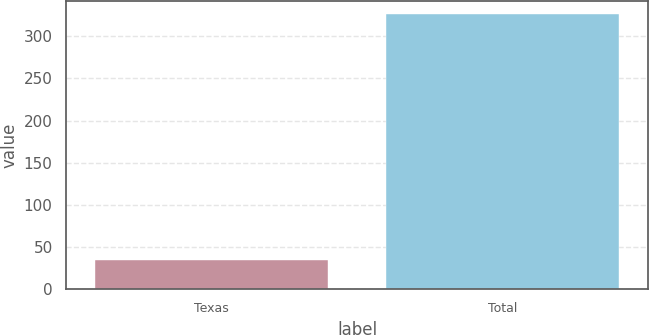Convert chart to OTSL. <chart><loc_0><loc_0><loc_500><loc_500><bar_chart><fcel>Texas<fcel>Total<nl><fcel>34<fcel>326<nl></chart> 